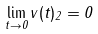Convert formula to latex. <formula><loc_0><loc_0><loc_500><loc_500>\lim _ { t \rightarrow 0 } \| v ( t ) \| _ { 2 } = 0</formula> 